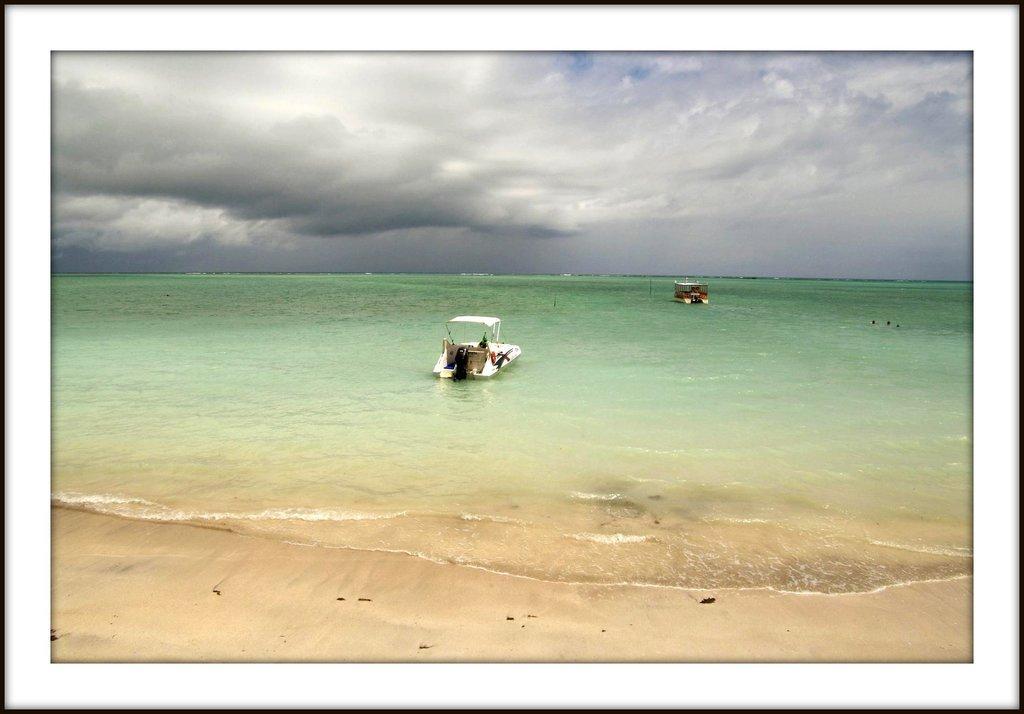Please provide a concise description of this image. In this image we can see a picture. In the picture there are ships on the sea and sky with clouds in the background. 